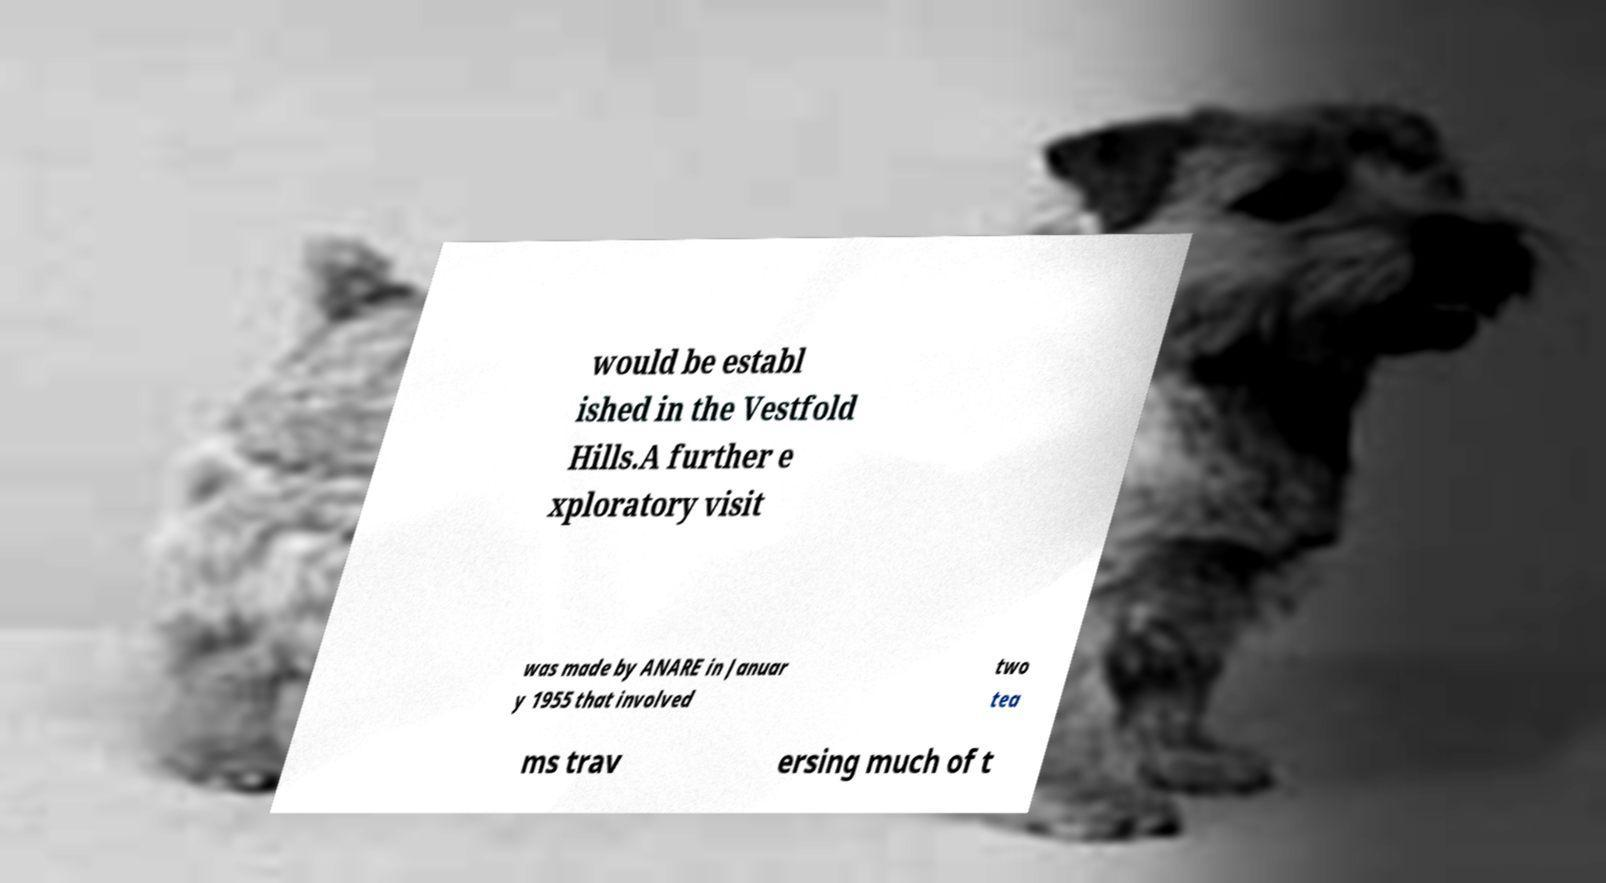Please identify and transcribe the text found in this image. would be establ ished in the Vestfold Hills.A further e xploratory visit was made by ANARE in Januar y 1955 that involved two tea ms trav ersing much of t 